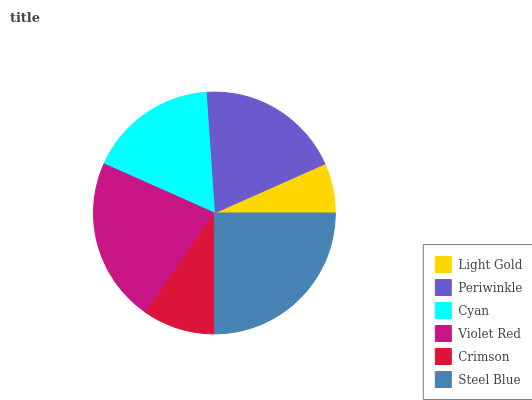Is Light Gold the minimum?
Answer yes or no. Yes. Is Steel Blue the maximum?
Answer yes or no. Yes. Is Periwinkle the minimum?
Answer yes or no. No. Is Periwinkle the maximum?
Answer yes or no. No. Is Periwinkle greater than Light Gold?
Answer yes or no. Yes. Is Light Gold less than Periwinkle?
Answer yes or no. Yes. Is Light Gold greater than Periwinkle?
Answer yes or no. No. Is Periwinkle less than Light Gold?
Answer yes or no. No. Is Periwinkle the high median?
Answer yes or no. Yes. Is Cyan the low median?
Answer yes or no. Yes. Is Cyan the high median?
Answer yes or no. No. Is Periwinkle the low median?
Answer yes or no. No. 